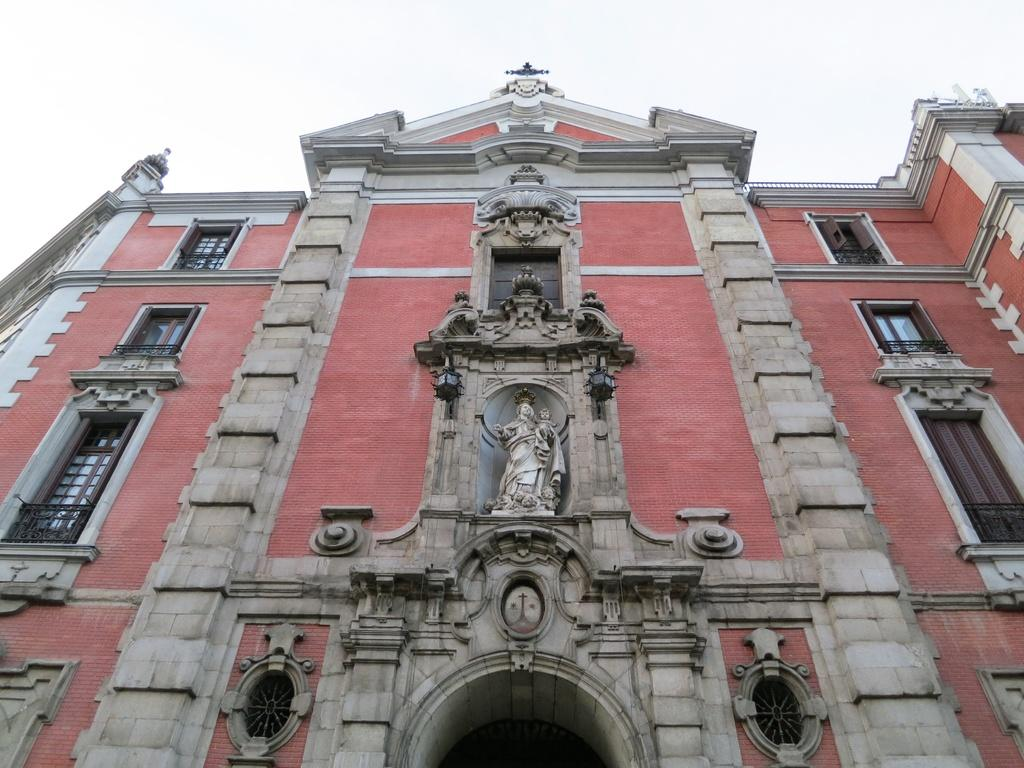What is the main structure in the image? There is a huge building in the image. What colors can be seen on the building? The building has cream, brown, and pink colors. What other object is present in the image? There is a statue in the image. What feature can be seen on the building? The building has windows. What is visible in the background of the image? The sky is visible in the background of the image. Can you tell me how many snails are crawling on the front of the building in the image? There are no snails present on the building in the image. What type of creature is shown interacting with the statue in the image? There is no creature shown interacting with the statue in the image; only the statue and the building are present. 